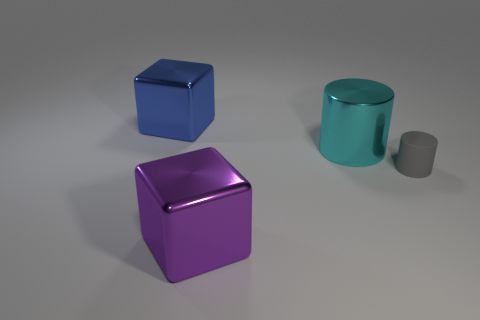Is there any other thing that has the same material as the tiny gray cylinder?
Keep it short and to the point. No. There is a small gray cylinder that is behind the metallic object that is in front of the small object; what is it made of?
Your response must be concise. Rubber. There is another block that is the same size as the blue block; what is its color?
Give a very brief answer. Purple. Does the big cyan shiny object have the same shape as the metal thing in front of the gray cylinder?
Your answer should be very brief. No. There is a big block that is to the left of the metal cube on the right side of the large blue thing; what number of shiny objects are in front of it?
Provide a succinct answer. 2. There is a thing right of the large thing that is on the right side of the big purple block; what is its size?
Provide a short and direct response. Small. There is a purple cube that is made of the same material as the cyan cylinder; what size is it?
Provide a short and direct response. Large. The thing that is both to the right of the purple metal cube and behind the tiny gray rubber object has what shape?
Offer a very short reply. Cylinder. Are there the same number of purple blocks in front of the matte thing and large brown rubber objects?
Offer a very short reply. No. What number of objects are either purple metallic blocks or things behind the purple object?
Keep it short and to the point. 4. 